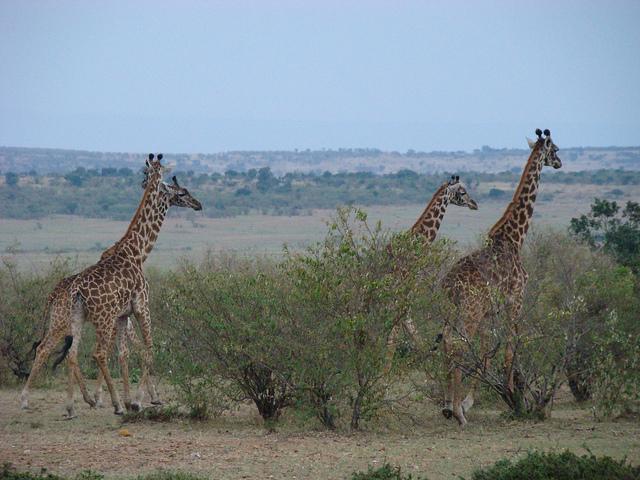How many animals?
Give a very brief answer. 3. How many animals are grazing?
Give a very brief answer. 4. How many giraffes are in the photo?
Give a very brief answer. 4. How many pieces of banana are on this plate?
Give a very brief answer. 0. 